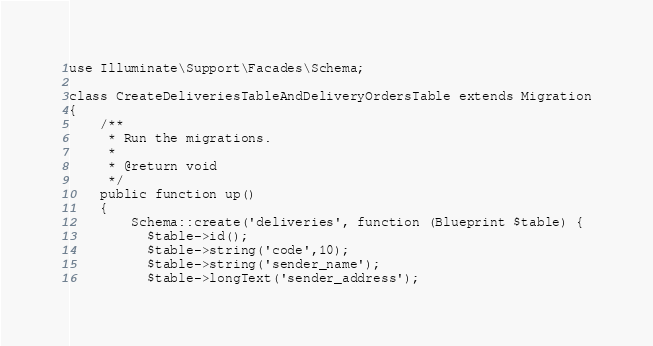Convert code to text. <code><loc_0><loc_0><loc_500><loc_500><_PHP_>use Illuminate\Support\Facades\Schema;

class CreateDeliveriesTableAndDeliveryOrdersTable extends Migration
{
    /**
     * Run the migrations.
     *
     * @return void
     */
    public function up()
    {
        Schema::create('deliveries', function (Blueprint $table) {
          $table->id();
          $table->string('code',10);
          $table->string('sender_name');
          $table->longText('sender_address');</code> 